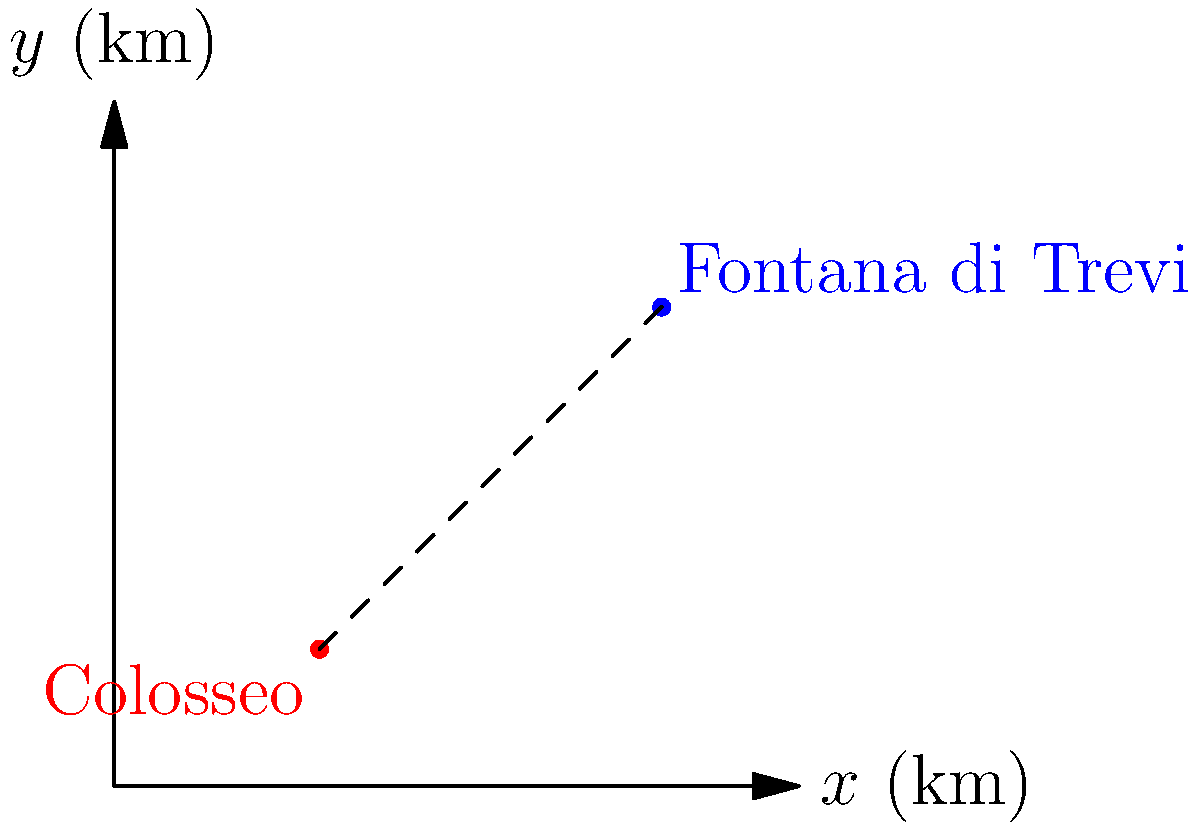Nel pianificare la tua avventura a Roma, vuoi calcolare la distanza tra il Colosseo e la Fontana di Trevi. Utilizzando le coordinate fornite nel grafico (in km), dove il Colosseo è situato a (3, 2) e la Fontana di Trevi a (8, 7), calcola la distanza euclidea tra questi due famosi luoghi turistici. Per calcolare la distanza euclidea tra due punti, utilizziamo la formula del vettore differenza:

1. Identifichiamo le coordinate:
   Colosseo: $A(3, 2)$
   Fontana di Trevi: $B(8, 7)$

2. Calcoliamo il vettore differenza $\vec{AB}$:
   $\vec{AB} = B - A = (8-3, 7-2) = (5, 5)$

3. Applichiamo la formula della distanza euclidea:
   $d = \sqrt{(x_2-x_1)^2 + (y_2-y_1)^2}$
   $d = \sqrt{5^2 + 5^2}$

4. Semplifichiamo:
   $d = \sqrt{25 + 25} = \sqrt{50}$

5. Semplifichiamo ulteriormente:
   $d = 5\sqrt{2} \approx 7.07$ km

Quindi, la distanza tra il Colosseo e la Fontana di Trevi è approssimativamente 7.07 km.
Answer: $5\sqrt{2}$ km o circa 7.07 km 